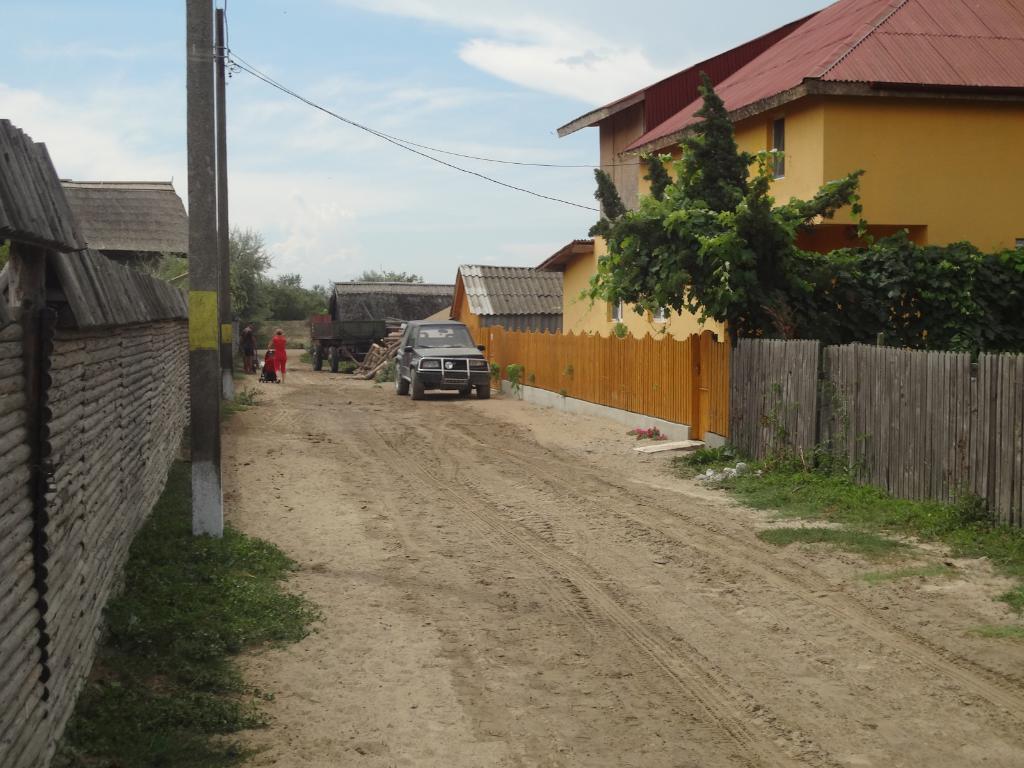Could you give a brief overview of what you see in this image? In this image I can see the road, some grass on the road, few poles, the fence walls and few buildings on both sides of the road. I can see a person standing and holding a stroller and a vehicle on the road. I can see few trees and in the background I can see the sky. 